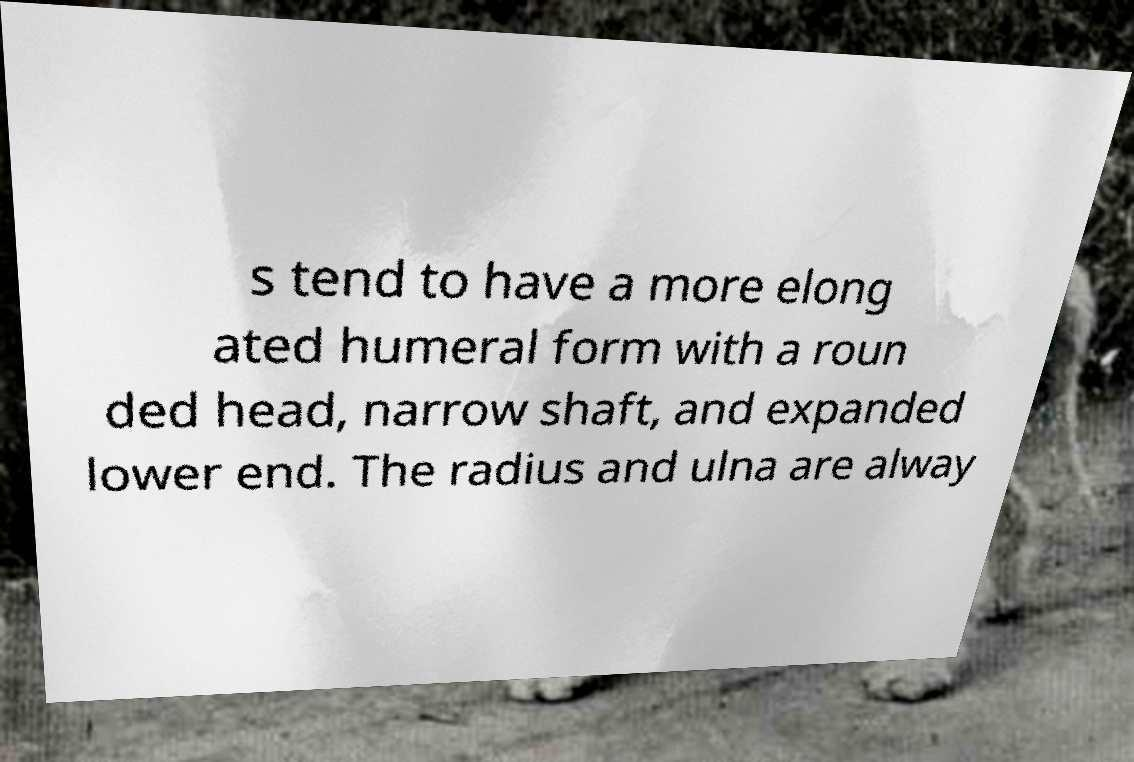Can you read and provide the text displayed in the image?This photo seems to have some interesting text. Can you extract and type it out for me? s tend to have a more elong ated humeral form with a roun ded head, narrow shaft, and expanded lower end. The radius and ulna are alway 